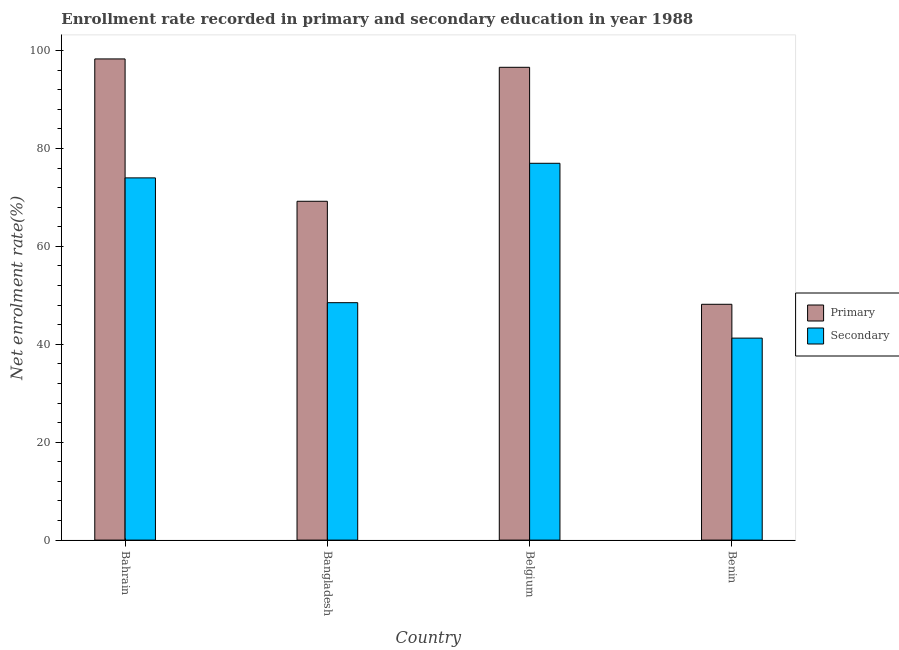Are the number of bars on each tick of the X-axis equal?
Offer a terse response. Yes. In how many cases, is the number of bars for a given country not equal to the number of legend labels?
Your answer should be compact. 0. What is the enrollment rate in secondary education in Benin?
Keep it short and to the point. 41.26. Across all countries, what is the maximum enrollment rate in secondary education?
Make the answer very short. 76.97. Across all countries, what is the minimum enrollment rate in secondary education?
Ensure brevity in your answer.  41.26. In which country was the enrollment rate in secondary education maximum?
Keep it short and to the point. Belgium. In which country was the enrollment rate in primary education minimum?
Offer a very short reply. Benin. What is the total enrollment rate in secondary education in the graph?
Offer a very short reply. 240.72. What is the difference between the enrollment rate in secondary education in Bahrain and that in Bangladesh?
Offer a terse response. 25.49. What is the difference between the enrollment rate in secondary education in Bangladesh and the enrollment rate in primary education in Benin?
Offer a very short reply. 0.33. What is the average enrollment rate in secondary education per country?
Ensure brevity in your answer.  60.18. What is the difference between the enrollment rate in secondary education and enrollment rate in primary education in Bahrain?
Provide a succinct answer. -24.3. What is the ratio of the enrollment rate in primary education in Belgium to that in Benin?
Provide a succinct answer. 2. Is the enrollment rate in secondary education in Bahrain less than that in Belgium?
Ensure brevity in your answer.  Yes. What is the difference between the highest and the second highest enrollment rate in primary education?
Provide a succinct answer. 1.71. What is the difference between the highest and the lowest enrollment rate in primary education?
Your response must be concise. 50.12. Is the sum of the enrollment rate in secondary education in Bahrain and Belgium greater than the maximum enrollment rate in primary education across all countries?
Make the answer very short. Yes. What does the 2nd bar from the left in Bahrain represents?
Offer a very short reply. Secondary. What does the 2nd bar from the right in Bahrain represents?
Make the answer very short. Primary. How many bars are there?
Make the answer very short. 8. Are all the bars in the graph horizontal?
Give a very brief answer. No. What is the difference between two consecutive major ticks on the Y-axis?
Your response must be concise. 20. Are the values on the major ticks of Y-axis written in scientific E-notation?
Give a very brief answer. No. Does the graph contain any zero values?
Your response must be concise. No. How many legend labels are there?
Provide a succinct answer. 2. How are the legend labels stacked?
Keep it short and to the point. Vertical. What is the title of the graph?
Offer a terse response. Enrollment rate recorded in primary and secondary education in year 1988. Does "Forest land" appear as one of the legend labels in the graph?
Keep it short and to the point. No. What is the label or title of the Y-axis?
Your response must be concise. Net enrolment rate(%). What is the Net enrolment rate(%) in Primary in Bahrain?
Your answer should be very brief. 98.29. What is the Net enrolment rate(%) in Secondary in Bahrain?
Your response must be concise. 73.99. What is the Net enrolment rate(%) in Primary in Bangladesh?
Make the answer very short. 69.21. What is the Net enrolment rate(%) in Secondary in Bangladesh?
Make the answer very short. 48.5. What is the Net enrolment rate(%) in Primary in Belgium?
Offer a very short reply. 96.58. What is the Net enrolment rate(%) in Secondary in Belgium?
Your response must be concise. 76.97. What is the Net enrolment rate(%) in Primary in Benin?
Your answer should be compact. 48.17. What is the Net enrolment rate(%) of Secondary in Benin?
Your answer should be compact. 41.26. Across all countries, what is the maximum Net enrolment rate(%) in Primary?
Provide a short and direct response. 98.29. Across all countries, what is the maximum Net enrolment rate(%) of Secondary?
Keep it short and to the point. 76.97. Across all countries, what is the minimum Net enrolment rate(%) of Primary?
Provide a short and direct response. 48.17. Across all countries, what is the minimum Net enrolment rate(%) of Secondary?
Your answer should be very brief. 41.26. What is the total Net enrolment rate(%) in Primary in the graph?
Provide a short and direct response. 312.24. What is the total Net enrolment rate(%) in Secondary in the graph?
Provide a succinct answer. 240.72. What is the difference between the Net enrolment rate(%) in Primary in Bahrain and that in Bangladesh?
Keep it short and to the point. 29.08. What is the difference between the Net enrolment rate(%) of Secondary in Bahrain and that in Bangladesh?
Your answer should be very brief. 25.49. What is the difference between the Net enrolment rate(%) of Primary in Bahrain and that in Belgium?
Make the answer very short. 1.71. What is the difference between the Net enrolment rate(%) of Secondary in Bahrain and that in Belgium?
Provide a short and direct response. -2.98. What is the difference between the Net enrolment rate(%) of Primary in Bahrain and that in Benin?
Provide a succinct answer. 50.12. What is the difference between the Net enrolment rate(%) of Secondary in Bahrain and that in Benin?
Your answer should be very brief. 32.73. What is the difference between the Net enrolment rate(%) in Primary in Bangladesh and that in Belgium?
Ensure brevity in your answer.  -27.37. What is the difference between the Net enrolment rate(%) in Secondary in Bangladesh and that in Belgium?
Offer a very short reply. -28.48. What is the difference between the Net enrolment rate(%) of Primary in Bangladesh and that in Benin?
Ensure brevity in your answer.  21.04. What is the difference between the Net enrolment rate(%) of Secondary in Bangladesh and that in Benin?
Offer a very short reply. 7.24. What is the difference between the Net enrolment rate(%) of Primary in Belgium and that in Benin?
Ensure brevity in your answer.  48.41. What is the difference between the Net enrolment rate(%) of Secondary in Belgium and that in Benin?
Offer a very short reply. 35.71. What is the difference between the Net enrolment rate(%) in Primary in Bahrain and the Net enrolment rate(%) in Secondary in Bangladesh?
Provide a short and direct response. 49.79. What is the difference between the Net enrolment rate(%) in Primary in Bahrain and the Net enrolment rate(%) in Secondary in Belgium?
Ensure brevity in your answer.  21.32. What is the difference between the Net enrolment rate(%) in Primary in Bahrain and the Net enrolment rate(%) in Secondary in Benin?
Give a very brief answer. 57.03. What is the difference between the Net enrolment rate(%) of Primary in Bangladesh and the Net enrolment rate(%) of Secondary in Belgium?
Keep it short and to the point. -7.76. What is the difference between the Net enrolment rate(%) of Primary in Bangladesh and the Net enrolment rate(%) of Secondary in Benin?
Ensure brevity in your answer.  27.95. What is the difference between the Net enrolment rate(%) in Primary in Belgium and the Net enrolment rate(%) in Secondary in Benin?
Offer a terse response. 55.32. What is the average Net enrolment rate(%) of Primary per country?
Your answer should be compact. 78.06. What is the average Net enrolment rate(%) of Secondary per country?
Ensure brevity in your answer.  60.18. What is the difference between the Net enrolment rate(%) of Primary and Net enrolment rate(%) of Secondary in Bahrain?
Offer a terse response. 24.3. What is the difference between the Net enrolment rate(%) of Primary and Net enrolment rate(%) of Secondary in Bangladesh?
Offer a very short reply. 20.71. What is the difference between the Net enrolment rate(%) of Primary and Net enrolment rate(%) of Secondary in Belgium?
Keep it short and to the point. 19.61. What is the difference between the Net enrolment rate(%) in Primary and Net enrolment rate(%) in Secondary in Benin?
Offer a terse response. 6.91. What is the ratio of the Net enrolment rate(%) of Primary in Bahrain to that in Bangladesh?
Offer a very short reply. 1.42. What is the ratio of the Net enrolment rate(%) in Secondary in Bahrain to that in Bangladesh?
Provide a succinct answer. 1.53. What is the ratio of the Net enrolment rate(%) in Primary in Bahrain to that in Belgium?
Keep it short and to the point. 1.02. What is the ratio of the Net enrolment rate(%) of Secondary in Bahrain to that in Belgium?
Keep it short and to the point. 0.96. What is the ratio of the Net enrolment rate(%) of Primary in Bahrain to that in Benin?
Offer a very short reply. 2.04. What is the ratio of the Net enrolment rate(%) of Secondary in Bahrain to that in Benin?
Provide a succinct answer. 1.79. What is the ratio of the Net enrolment rate(%) of Primary in Bangladesh to that in Belgium?
Keep it short and to the point. 0.72. What is the ratio of the Net enrolment rate(%) of Secondary in Bangladesh to that in Belgium?
Offer a very short reply. 0.63. What is the ratio of the Net enrolment rate(%) of Primary in Bangladesh to that in Benin?
Offer a very short reply. 1.44. What is the ratio of the Net enrolment rate(%) of Secondary in Bangladesh to that in Benin?
Give a very brief answer. 1.18. What is the ratio of the Net enrolment rate(%) in Primary in Belgium to that in Benin?
Ensure brevity in your answer.  2. What is the ratio of the Net enrolment rate(%) in Secondary in Belgium to that in Benin?
Provide a short and direct response. 1.87. What is the difference between the highest and the second highest Net enrolment rate(%) of Primary?
Keep it short and to the point. 1.71. What is the difference between the highest and the second highest Net enrolment rate(%) of Secondary?
Make the answer very short. 2.98. What is the difference between the highest and the lowest Net enrolment rate(%) of Primary?
Make the answer very short. 50.12. What is the difference between the highest and the lowest Net enrolment rate(%) of Secondary?
Ensure brevity in your answer.  35.71. 